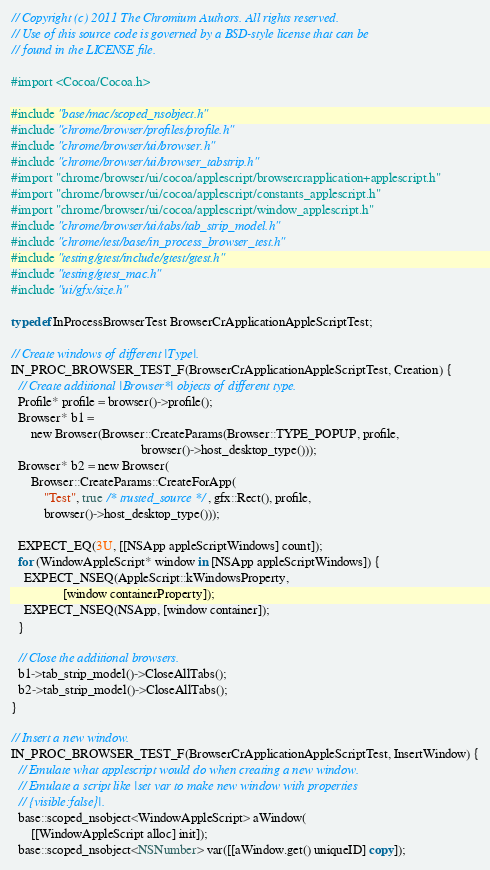Convert code to text. <code><loc_0><loc_0><loc_500><loc_500><_ObjectiveC_>// Copyright (c) 2011 The Chromium Authors. All rights reserved.
// Use of this source code is governed by a BSD-style license that can be
// found in the LICENSE file.

#import <Cocoa/Cocoa.h>

#include "base/mac/scoped_nsobject.h"
#include "chrome/browser/profiles/profile.h"
#include "chrome/browser/ui/browser.h"
#include "chrome/browser/ui/browser_tabstrip.h"
#import "chrome/browser/ui/cocoa/applescript/browsercrapplication+applescript.h"
#import "chrome/browser/ui/cocoa/applescript/constants_applescript.h"
#import "chrome/browser/ui/cocoa/applescript/window_applescript.h"
#include "chrome/browser/ui/tabs/tab_strip_model.h"
#include "chrome/test/base/in_process_browser_test.h"
#include "testing/gtest/include/gtest/gtest.h"
#include "testing/gtest_mac.h"
#include "ui/gfx/size.h"

typedef InProcessBrowserTest BrowserCrApplicationAppleScriptTest;

// Create windows of different |Type|.
IN_PROC_BROWSER_TEST_F(BrowserCrApplicationAppleScriptTest, Creation) {
  // Create additional |Browser*| objects of different type.
  Profile* profile = browser()->profile();
  Browser* b1 =
      new Browser(Browser::CreateParams(Browser::TYPE_POPUP, profile,
                                        browser()->host_desktop_type()));
  Browser* b2 = new Browser(
      Browser::CreateParams::CreateForApp(
          "Test", true /* trusted_source */, gfx::Rect(), profile,
          browser()->host_desktop_type()));

  EXPECT_EQ(3U, [[NSApp appleScriptWindows] count]);
  for (WindowAppleScript* window in [NSApp appleScriptWindows]) {
    EXPECT_NSEQ(AppleScript::kWindowsProperty,
                [window containerProperty]);
    EXPECT_NSEQ(NSApp, [window container]);
  }

  // Close the additional browsers.
  b1->tab_strip_model()->CloseAllTabs();
  b2->tab_strip_model()->CloseAllTabs();
}

// Insert a new window.
IN_PROC_BROWSER_TEST_F(BrowserCrApplicationAppleScriptTest, InsertWindow) {
  // Emulate what applescript would do when creating a new window.
  // Emulate a script like |set var to make new window with properties
  // {visible:false}|.
  base::scoped_nsobject<WindowAppleScript> aWindow(
      [[WindowAppleScript alloc] init]);
  base::scoped_nsobject<NSNumber> var([[aWindow.get() uniqueID] copy]);</code> 